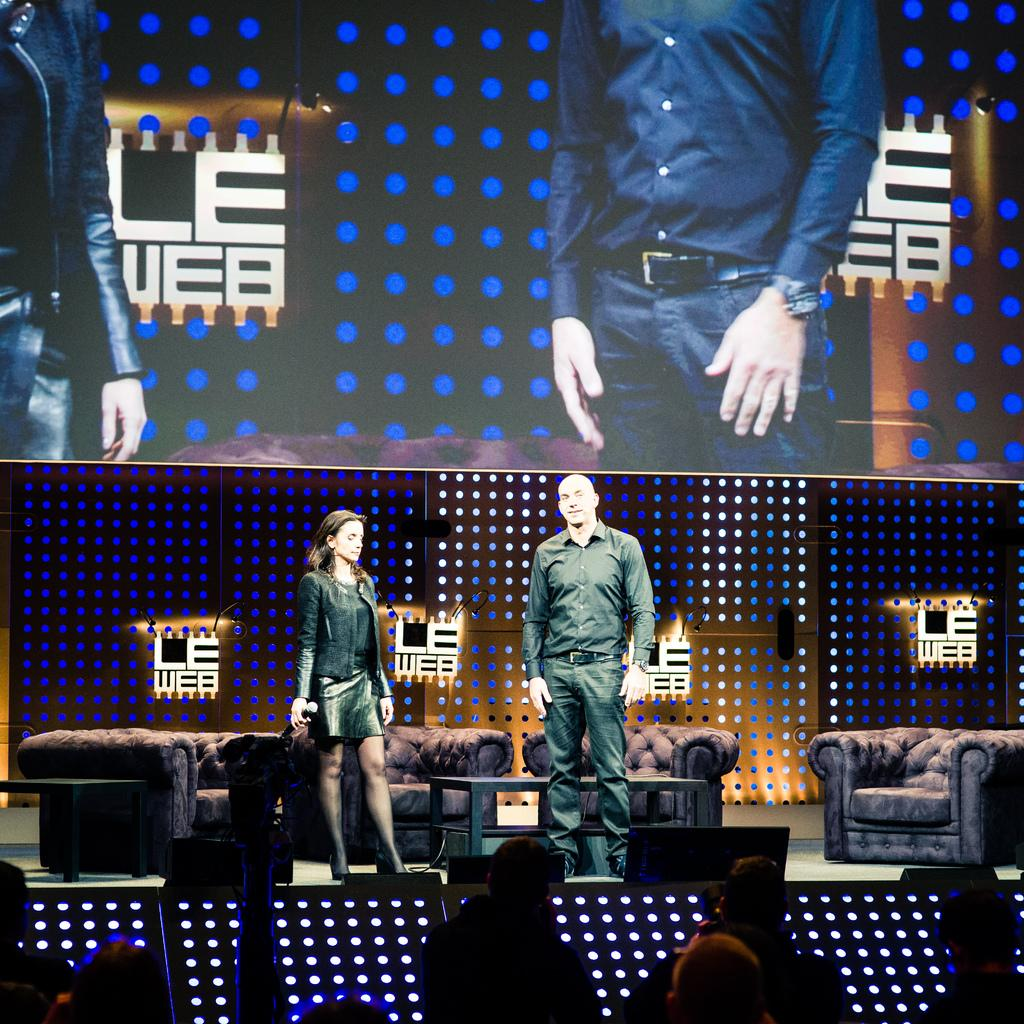What is the main object in the image? There is a screen in the image. What can be seen on the screen? Two people are visible on the screen. What else is present on the stage? There are people on the stage, chairs, and a table. Who is present in the room where the image was taken? The audience is visible in the image. What type of wound can be seen on the pipe in the image? There is no pipe present in the image, and therefore no wound can be observed. 